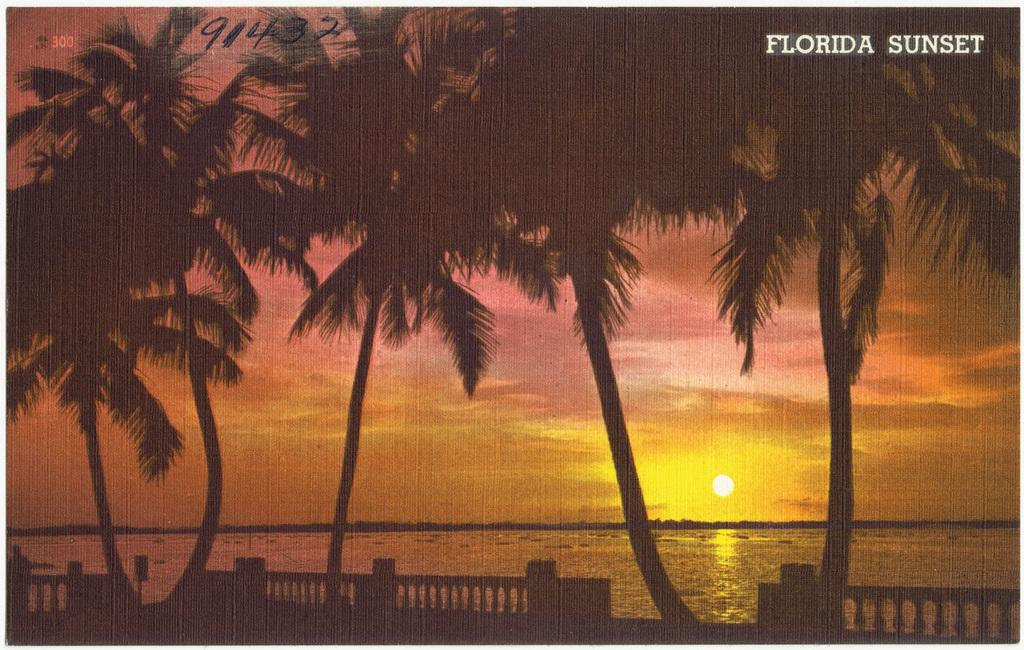What type of vegetation can be seen in the image? There are trees in the image. What type of barrier is present in the image? There is a fence in the image. How would you describe the weather in the image? The sky is cloudy, but the sun is also visible in the image. What natural feature can be seen in the image? There is a sea visible in the image. Where is the text located in the image? The text is in the top right corner of the image. What type of throne is visible in the image? There is no throne present in the image. What color is the skirt worn by the tree in the image? There are no skirts or trees wearing clothing in the image. How many flowers can be seen growing on the fence in the image? There are no flowers visible on the fence in the image. 